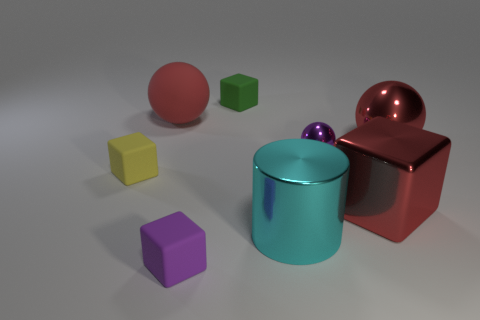Subtract all big spheres. How many spheres are left? 1 Add 1 tiny balls. How many objects exist? 9 Subtract all purple balls. How many balls are left? 2 Subtract 1 cubes. How many cubes are left? 3 Subtract all balls. How many objects are left? 5 Subtract all red cylinders. How many yellow balls are left? 0 Subtract all big blue metallic things. Subtract all small purple matte cubes. How many objects are left? 7 Add 7 purple rubber objects. How many purple rubber objects are left? 8 Add 4 small red cubes. How many small red cubes exist? 4 Subtract 1 cyan cylinders. How many objects are left? 7 